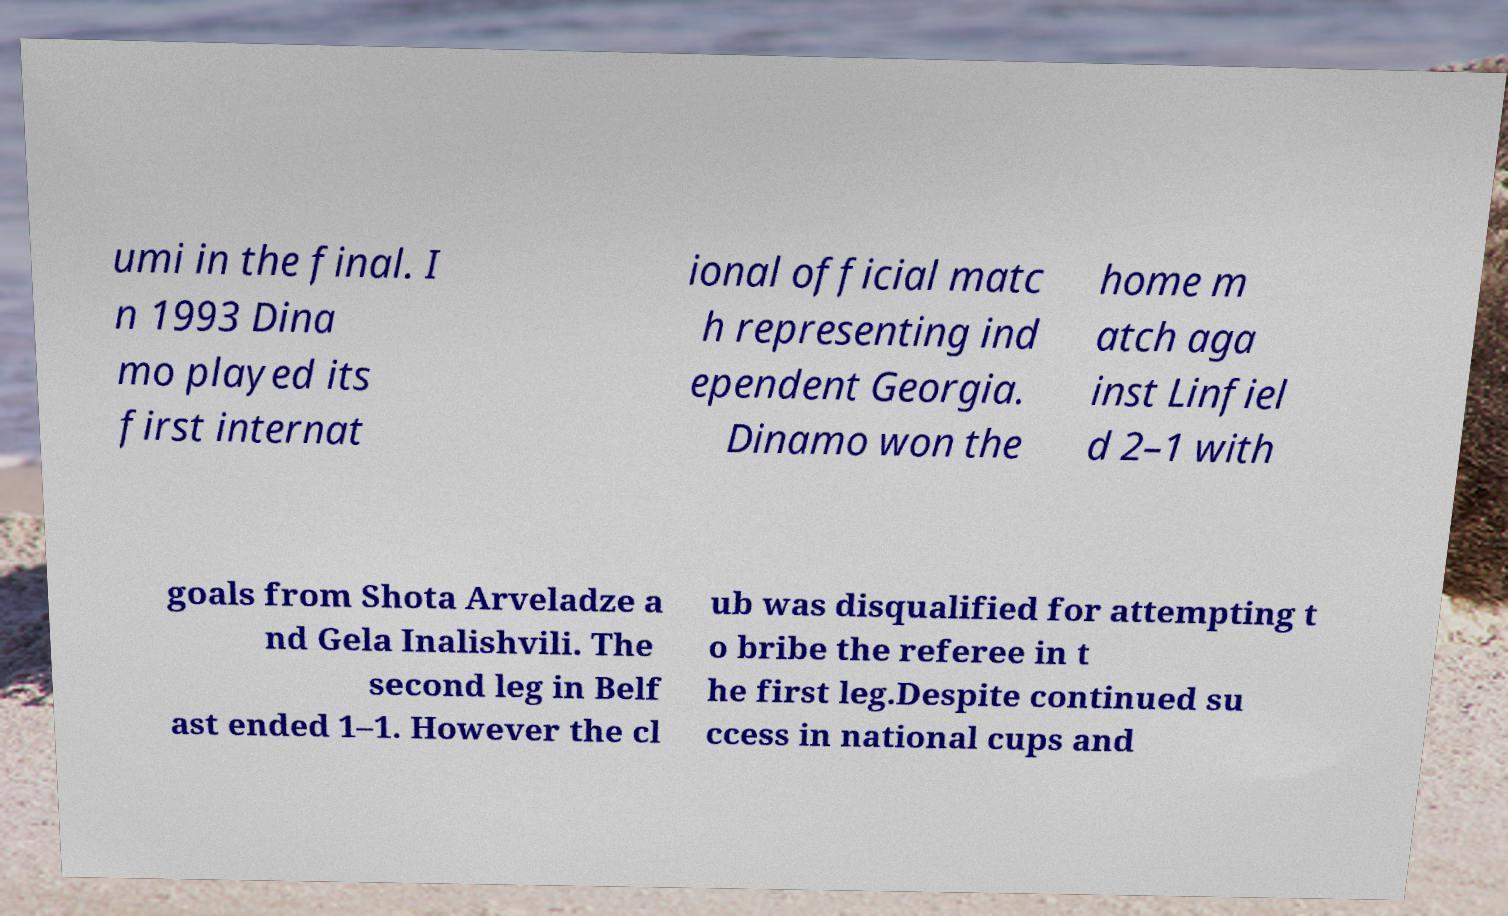Can you read and provide the text displayed in the image?This photo seems to have some interesting text. Can you extract and type it out for me? umi in the final. I n 1993 Dina mo played its first internat ional official matc h representing ind ependent Georgia. Dinamo won the home m atch aga inst Linfiel d 2–1 with goals from Shota Arveladze a nd Gela Inalishvili. The second leg in Belf ast ended 1–1. However the cl ub was disqualified for attempting t o bribe the referee in t he first leg.Despite continued su ccess in national cups and 